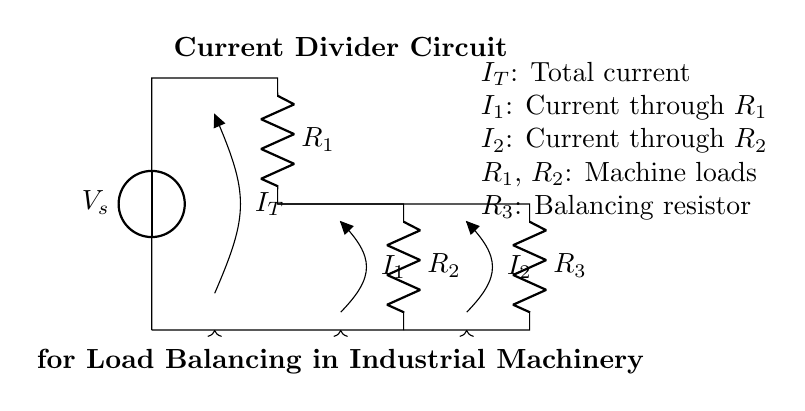What is the source voltage in this circuit? The source voltage, denoted by V_s at the top of the circuit, is the voltage supplied to the entire circuit. According to the diagram, it does not specify a numerical value, but it represents the input voltage for this current divider circuit.
Answer: V_s How many resistors are present in the circuit? The circuit contains three resistors, labeled R_1, R_2, and R_3. These resistors are positioned in such a way to create two parallel paths for the current to divide between them effectively.
Answer: 3 What are the names of the currents in the circuit? The circuit has three currents identified: I_T for total current flowing from the source, I_1 flowing through resistor R_1, and I_2 through resistor R_2. Each current is indicated with an arrow and labeled accordingly in the diagram.
Answer: I_T, I_1, I_2 Which resistors are considered machine loads? Resistors R_1 and R_2 are specifically labeled as machine loads in the circuit. This labeling indicates that they represent the loads that the machine operates under in this current divider configuration, distributing the total current between them.
Answer: R_1, R_2 If resistor R_3 is a balancing resistor, what is its role in the circuit? Resistor R_3 is connected in parallel with R_1 and R_2 to help balance the current between them, ensuring that no single load is overloaded. The current divider circuit relies on this resistor to maintain a proper division of current, helping to stabilize the entire circuit's operation.
Answer: Balance current What relationship exists between the currents I_1 and I_2? In a current divider circuit, the current through each resistor (I_1 and I_2) is inversely proportional to the resistance value. This means that if one resistance increases, the current through that path decreases, thereby affecting the current through the other path due to the conservation of current in the circuit.
Answer: Inverse proportion How does the total current I_T relate to the individual currents I_1 and I_2? The total current I_T is equal to the sum of the currents I_1 and I_2 in a parallel circuit configuration. This relationship is due to Kirchhoff's Current Law, which states that the total current entering a junction equals the total current leaving that junction. Therefore, in this case, I_T = I_1 + I_2.
Answer: I_T = I_1 + I_2 